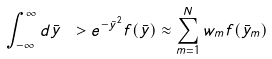<formula> <loc_0><loc_0><loc_500><loc_500>\int _ { - \infty } ^ { \infty } d { \bar { y } } \ > e ^ { - { \bar { y } } ^ { 2 } } f ( { \bar { y } } ) \approx \sum _ { m = 1 } ^ { N } w _ { m } f ( { \bar { y } } _ { m } )</formula> 